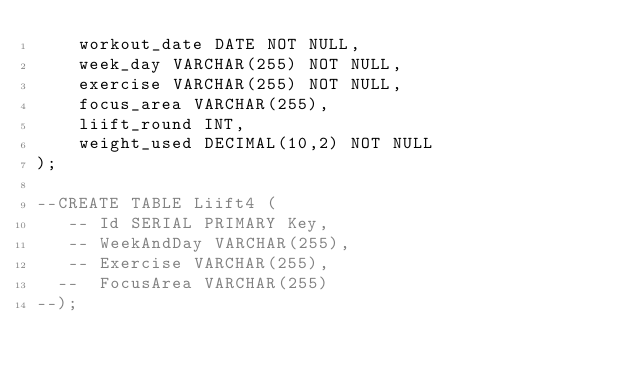Convert code to text. <code><loc_0><loc_0><loc_500><loc_500><_SQL_>    workout_date DATE NOT NULL,
    week_day VARCHAR(255) NOT NULL,
    exercise VARCHAR(255) NOT NULL,
    focus_area VARCHAR(255),
    liift_round INT,
    weight_used DECIMAL(10,2) NOT NULL
);

--CREATE TABLE Liift4 (
   -- Id SERIAL PRIMARY Key,
   -- WeekAndDay VARCHAR(255),
   -- Exercise VARCHAR(255),
  --  FocusArea VARCHAR(255)
--);</code> 